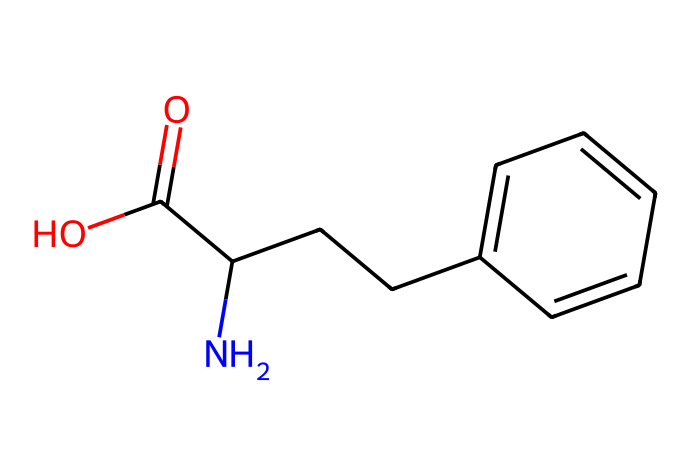What is the main functional group in phenibut? The SMILES representation shows a carboxylic acid functional group (represented by C(=O)O) attached to the carbon chain. This indicates phenibut has a carboxylic acid functional group.
Answer: carboxylic acid How many carbon atoms are in phenibut? Counting the carbon atoms from the SMILES, there are a total of 9 carbon atoms (one from the carboxylic acid and eight in the remaining structure).
Answer: 9 What type of bonding is primarily found in phenibut? The SMILES structure shows single bonds primarily between the carbon atoms and between carbon and nitrogen, indicating that standard covalent bonding characteristics are present in the compound.
Answer: covalent Is phenibut a cyclic or acyclic compound? The structure depicted in the SMILES is a straight chain and does not contain any rings, confirming that phenibut is acyclic.
Answer: acyclic What is the total number of hydrogen atoms in phenibut? Upon analyzing the carbon atoms and their respective bonding (with nitrogen and oxygen), there are a total of 11 hydrogen atoms in the structure, as each carbon typically bonds with hydrogen to complete its tetravalency.
Answer: 11 Which element is directly responsible for the compound's potential anxiolytic properties? The presence of nitrogen coded in the SMILES structure, specifically in the amine group (part of the carbon chain), is linked with the activity of gabapentinoids in targeting GABA receptors, explaining the anxiolytic properties.
Answer: nitrogen 